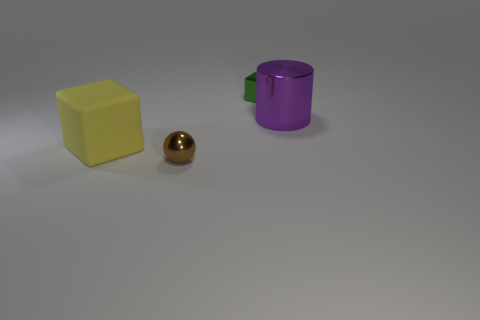Are there any other things that have the same shape as the large shiny object?
Provide a short and direct response. No. What size is the block that is in front of the big thing that is right of the small thing that is behind the large purple metal cylinder?
Offer a very short reply. Large. Is the number of large objects that are behind the large cube greater than the number of small brown rubber things?
Give a very brief answer. Yes. Are any small green shiny blocks visible?
Keep it short and to the point. Yes. What number of other blocks have the same size as the rubber block?
Make the answer very short. 0. Are there more shiny blocks behind the big rubber object than small brown shiny balls behind the small brown thing?
Offer a terse response. Yes. What is the material of the purple cylinder that is the same size as the yellow thing?
Keep it short and to the point. Metal. The tiny brown metallic thing has what shape?
Your response must be concise. Sphere. How many purple objects are big shiny cylinders or large things?
Your answer should be compact. 1. The purple cylinder that is the same material as the small brown ball is what size?
Keep it short and to the point. Large. 